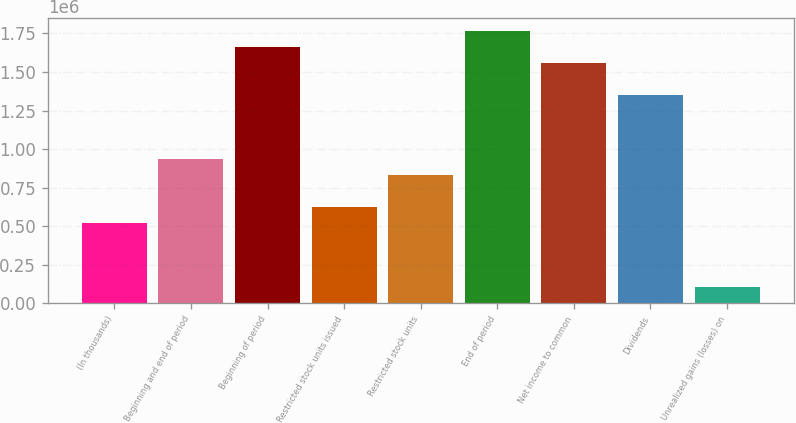<chart> <loc_0><loc_0><loc_500><loc_500><bar_chart><fcel>(In thousands)<fcel>Beginning and end of period<fcel>Beginning of period<fcel>Restricted stock units issued<fcel>Restricted stock units<fcel>End of period<fcel>Net income to common<fcel>Dividends<fcel>Unrealized gains (losses) on<nl><fcel>518752<fcel>933707<fcel>1.65988e+06<fcel>622491<fcel>829969<fcel>1.76362e+06<fcel>1.55614e+06<fcel>1.34866e+06<fcel>103798<nl></chart> 